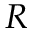Convert formula to latex. <formula><loc_0><loc_0><loc_500><loc_500>R</formula> 